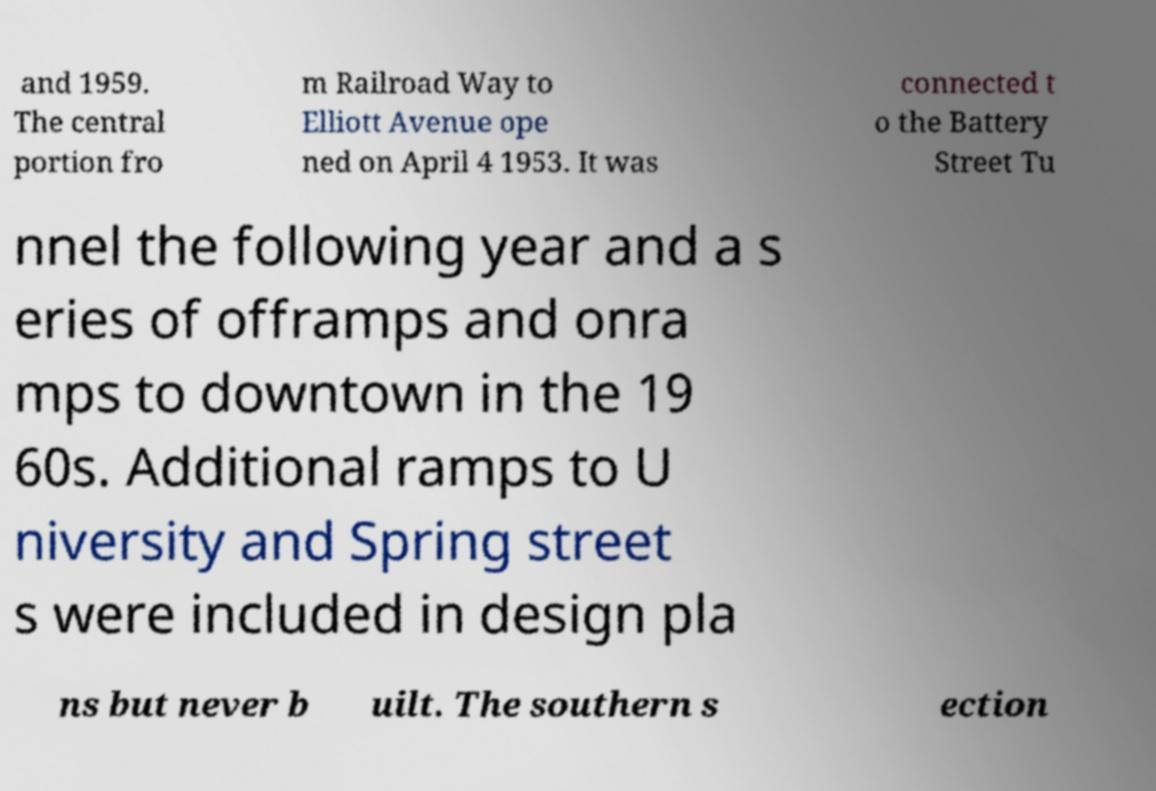Could you extract and type out the text from this image? and 1959. The central portion fro m Railroad Way to Elliott Avenue ope ned on April 4 1953. It was connected t o the Battery Street Tu nnel the following year and a s eries of offramps and onra mps to downtown in the 19 60s. Additional ramps to U niversity and Spring street s were included in design pla ns but never b uilt. The southern s ection 